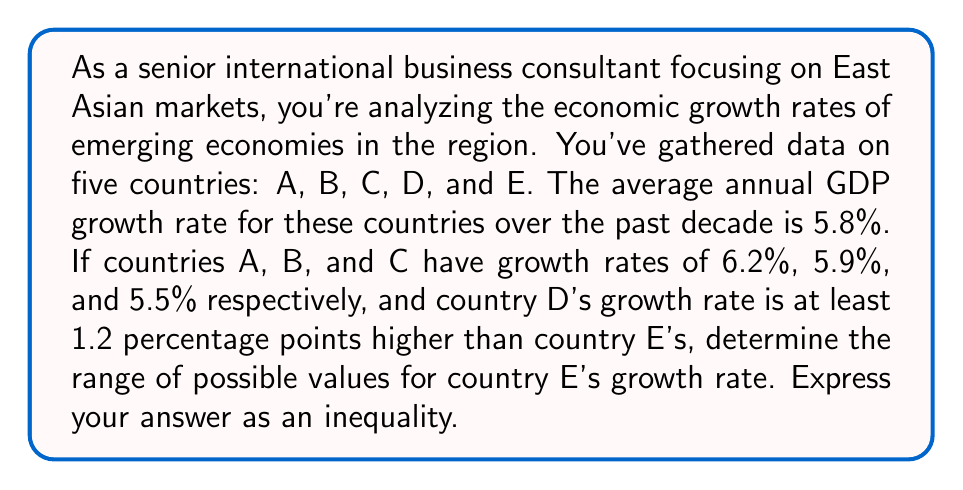Give your solution to this math problem. Let's approach this step-by-step:

1) Let $x$ be country E's growth rate and $y$ be country D's growth rate.

2) We know that $y \geq x + 1.2$

3) The average growth rate of all five countries is 5.8%. We can express this as an equation:

   $\frac{6.2 + 5.9 + 5.5 + y + x}{5} = 5.8$

4) Multiply both sides by 5:

   $6.2 + 5.9 + 5.5 + y + x = 29$

5) Simplify:

   $17.6 + y + x = 29$

6) Subtract 17.6 from both sides:

   $y + x = 11.4$

7) Substitute $y \geq x + 1.2$ into this equation:

   $(x + 1.2) + x \geq 11.4$

8) Simplify:

   $2x + 1.2 \geq 11.4$

9) Subtract 1.2 from both sides:

   $2x \geq 10.2$

10) Divide by 2:

    $x \geq 5.1$

11) Therefore, country E's growth rate must be at least 5.1%.

12) To find the upper bound, we use the fact that country D's rate must be less than or equal to the highest given rate (6.2%):

    $y \leq 6.2$

13) Substitute this into the equation from step 6:

    $6.2 + x \leq 11.4$

14) Subtract 6.2 from both sides:

    $x \leq 5.2$

Thus, country E's growth rate $x$ must satisfy: $5.1 \leq x \leq 5.2$
Answer: $5.1 \leq x \leq 5.2$, where $x$ is country E's economic growth rate. 